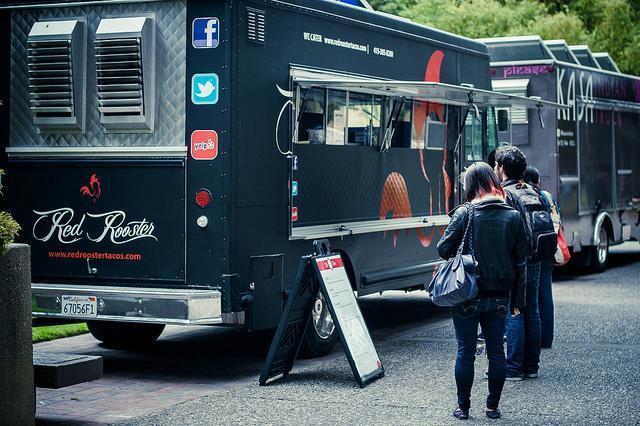How many people can you see?
Give a very brief answer. 2. How many handbags are there?
Give a very brief answer. 1. How many trucks are there?
Give a very brief answer. 2. 